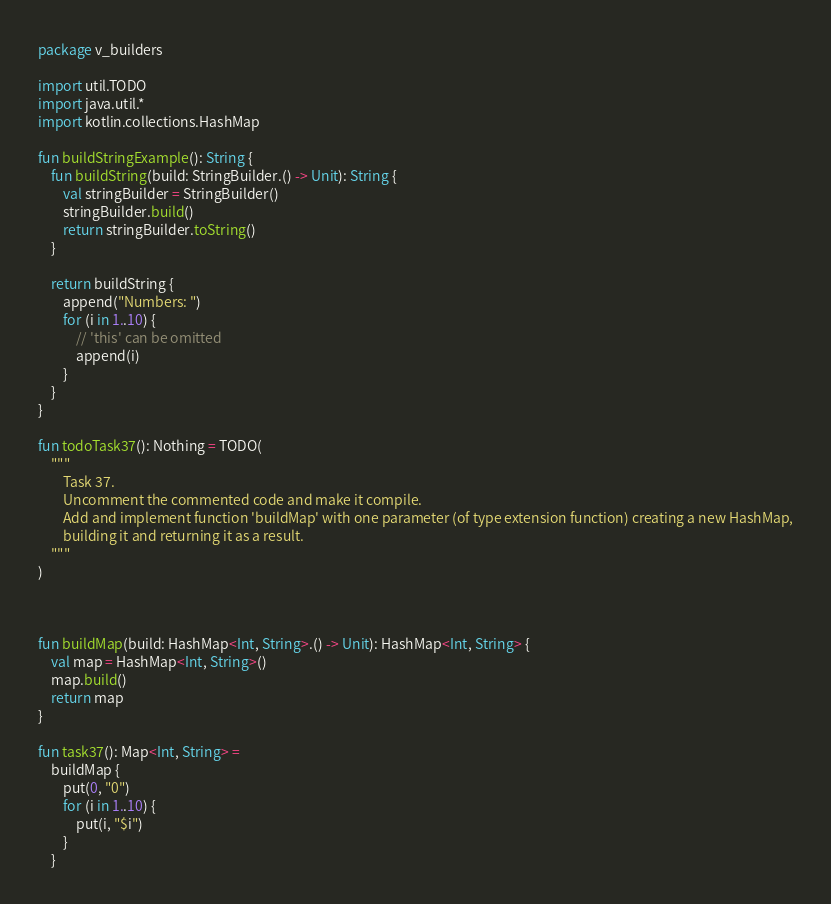Convert code to text. <code><loc_0><loc_0><loc_500><loc_500><_Kotlin_>package v_builders

import util.TODO
import java.util.*
import kotlin.collections.HashMap

fun buildStringExample(): String {
    fun buildString(build: StringBuilder.() -> Unit): String {
        val stringBuilder = StringBuilder()
        stringBuilder.build()
        return stringBuilder.toString()
    }

    return buildString {
        append("Numbers: ")
        for (i in 1..10) {
            // 'this' can be omitted
            append(i)
        }
    }
}

fun todoTask37(): Nothing = TODO(
    """
        Task 37.
        Uncomment the commented code and make it compile.
        Add and implement function 'buildMap' with one parameter (of type extension function) creating a new HashMap,
        building it and returning it as a result.
    """
)



fun buildMap(build: HashMap<Int, String>.() -> Unit): HashMap<Int, String> {
    val map = HashMap<Int, String>()
    map.build()
    return map
}

fun task37(): Map<Int, String> =
    buildMap {
        put(0, "0")
        for (i in 1..10) {
            put(i, "$i")
        }
    }

</code> 